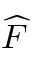<formula> <loc_0><loc_0><loc_500><loc_500>\widehat { F }</formula> 